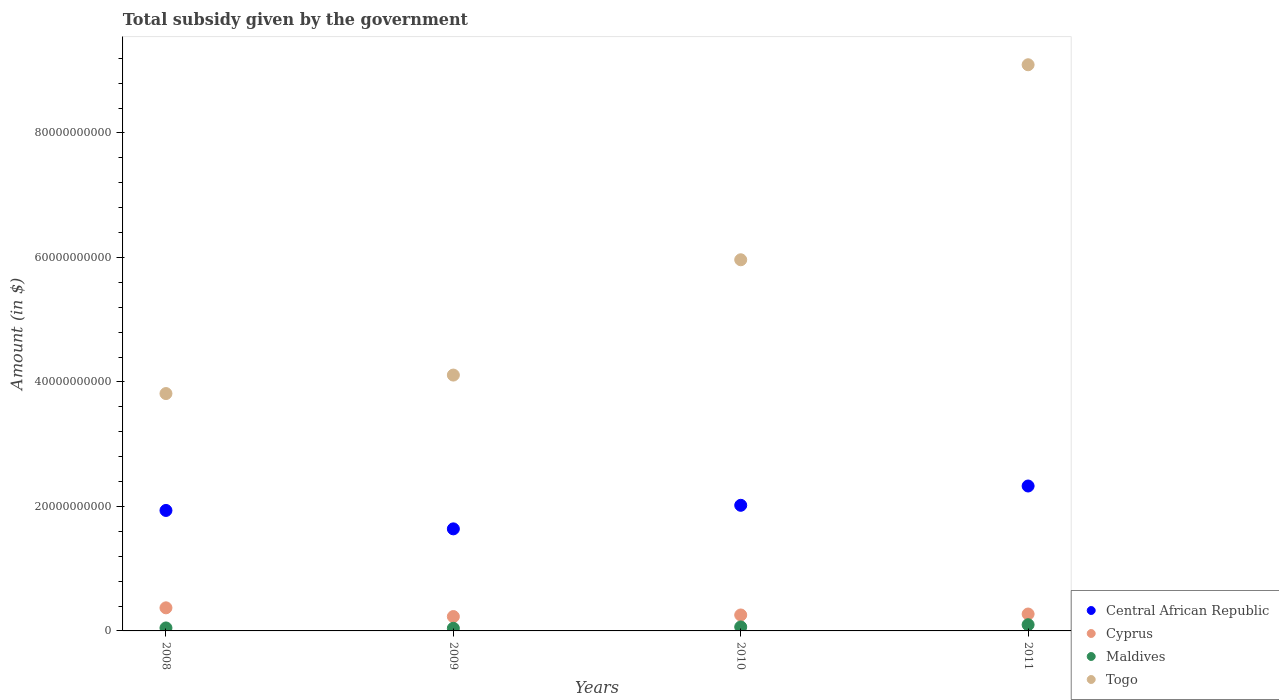What is the total revenue collected by the government in Cyprus in 2011?
Your answer should be very brief. 2.71e+09. Across all years, what is the maximum total revenue collected by the government in Maldives?
Offer a terse response. 9.97e+08. Across all years, what is the minimum total revenue collected by the government in Cyprus?
Keep it short and to the point. 2.31e+09. In which year was the total revenue collected by the government in Central African Republic maximum?
Your answer should be compact. 2011. In which year was the total revenue collected by the government in Maldives minimum?
Provide a succinct answer. 2009. What is the total total revenue collected by the government in Cyprus in the graph?
Offer a very short reply. 1.13e+1. What is the difference between the total revenue collected by the government in Maldives in 2009 and that in 2010?
Provide a succinct answer. -2.17e+08. What is the difference between the total revenue collected by the government in Central African Republic in 2011 and the total revenue collected by the government in Togo in 2010?
Keep it short and to the point. -3.63e+1. What is the average total revenue collected by the government in Togo per year?
Ensure brevity in your answer.  5.75e+1. In the year 2010, what is the difference between the total revenue collected by the government in Cyprus and total revenue collected by the government in Central African Republic?
Offer a terse response. -1.76e+1. What is the ratio of the total revenue collected by the government in Central African Republic in 2008 to that in 2009?
Your response must be concise. 1.18. Is the total revenue collected by the government in Togo in 2008 less than that in 2009?
Your response must be concise. Yes. Is the difference between the total revenue collected by the government in Cyprus in 2008 and 2011 greater than the difference between the total revenue collected by the government in Central African Republic in 2008 and 2011?
Offer a very short reply. Yes. What is the difference between the highest and the second highest total revenue collected by the government in Maldives?
Your answer should be very brief. 3.58e+08. What is the difference between the highest and the lowest total revenue collected by the government in Central African Republic?
Make the answer very short. 6.88e+09. In how many years, is the total revenue collected by the government in Togo greater than the average total revenue collected by the government in Togo taken over all years?
Offer a terse response. 2. Is the sum of the total revenue collected by the government in Cyprus in 2008 and 2010 greater than the maximum total revenue collected by the government in Maldives across all years?
Provide a succinct answer. Yes. Is it the case that in every year, the sum of the total revenue collected by the government in Togo and total revenue collected by the government in Maldives  is greater than the sum of total revenue collected by the government in Cyprus and total revenue collected by the government in Central African Republic?
Give a very brief answer. No. Is the total revenue collected by the government in Maldives strictly greater than the total revenue collected by the government in Togo over the years?
Give a very brief answer. No. Is the total revenue collected by the government in Togo strictly less than the total revenue collected by the government in Maldives over the years?
Give a very brief answer. No. Does the graph contain any zero values?
Provide a succinct answer. No. How many legend labels are there?
Make the answer very short. 4. What is the title of the graph?
Ensure brevity in your answer.  Total subsidy given by the government. Does "Japan" appear as one of the legend labels in the graph?
Give a very brief answer. No. What is the label or title of the Y-axis?
Provide a short and direct response. Amount (in $). What is the Amount (in $) of Central African Republic in 2008?
Keep it short and to the point. 1.94e+1. What is the Amount (in $) of Cyprus in 2008?
Your answer should be compact. 3.71e+09. What is the Amount (in $) of Maldives in 2008?
Ensure brevity in your answer.  4.79e+08. What is the Amount (in $) in Togo in 2008?
Offer a terse response. 3.81e+1. What is the Amount (in $) in Central African Republic in 2009?
Ensure brevity in your answer.  1.64e+1. What is the Amount (in $) of Cyprus in 2009?
Provide a succinct answer. 2.31e+09. What is the Amount (in $) in Maldives in 2009?
Offer a terse response. 4.22e+08. What is the Amount (in $) of Togo in 2009?
Provide a succinct answer. 4.11e+1. What is the Amount (in $) in Central African Republic in 2010?
Keep it short and to the point. 2.02e+1. What is the Amount (in $) in Cyprus in 2010?
Your answer should be compact. 2.56e+09. What is the Amount (in $) in Maldives in 2010?
Your response must be concise. 6.39e+08. What is the Amount (in $) in Togo in 2010?
Keep it short and to the point. 5.96e+1. What is the Amount (in $) of Central African Republic in 2011?
Give a very brief answer. 2.33e+1. What is the Amount (in $) in Cyprus in 2011?
Provide a short and direct response. 2.71e+09. What is the Amount (in $) of Maldives in 2011?
Give a very brief answer. 9.97e+08. What is the Amount (in $) of Togo in 2011?
Offer a terse response. 9.10e+1. Across all years, what is the maximum Amount (in $) of Central African Republic?
Offer a terse response. 2.33e+1. Across all years, what is the maximum Amount (in $) of Cyprus?
Your response must be concise. 3.71e+09. Across all years, what is the maximum Amount (in $) of Maldives?
Keep it short and to the point. 9.97e+08. Across all years, what is the maximum Amount (in $) in Togo?
Give a very brief answer. 9.10e+1. Across all years, what is the minimum Amount (in $) of Central African Republic?
Provide a succinct answer. 1.64e+1. Across all years, what is the minimum Amount (in $) in Cyprus?
Your response must be concise. 2.31e+09. Across all years, what is the minimum Amount (in $) in Maldives?
Provide a short and direct response. 4.22e+08. Across all years, what is the minimum Amount (in $) of Togo?
Your answer should be very brief. 3.81e+1. What is the total Amount (in $) in Central African Republic in the graph?
Offer a very short reply. 7.92e+1. What is the total Amount (in $) in Cyprus in the graph?
Your answer should be very brief. 1.13e+1. What is the total Amount (in $) in Maldives in the graph?
Offer a terse response. 2.54e+09. What is the total Amount (in $) of Togo in the graph?
Offer a very short reply. 2.30e+11. What is the difference between the Amount (in $) of Central African Republic in 2008 and that in 2009?
Your answer should be very brief. 2.96e+09. What is the difference between the Amount (in $) in Cyprus in 2008 and that in 2009?
Provide a short and direct response. 1.40e+09. What is the difference between the Amount (in $) in Maldives in 2008 and that in 2009?
Your response must be concise. 5.76e+07. What is the difference between the Amount (in $) of Togo in 2008 and that in 2009?
Your response must be concise. -2.97e+09. What is the difference between the Amount (in $) in Central African Republic in 2008 and that in 2010?
Your answer should be compact. -8.27e+08. What is the difference between the Amount (in $) in Cyprus in 2008 and that in 2010?
Your answer should be compact. 1.15e+09. What is the difference between the Amount (in $) in Maldives in 2008 and that in 2010?
Your response must be concise. -1.60e+08. What is the difference between the Amount (in $) in Togo in 2008 and that in 2010?
Keep it short and to the point. -2.15e+1. What is the difference between the Amount (in $) in Central African Republic in 2008 and that in 2011?
Keep it short and to the point. -3.93e+09. What is the difference between the Amount (in $) of Cyprus in 2008 and that in 2011?
Your answer should be compact. 9.95e+08. What is the difference between the Amount (in $) of Maldives in 2008 and that in 2011?
Offer a very short reply. -5.18e+08. What is the difference between the Amount (in $) in Togo in 2008 and that in 2011?
Ensure brevity in your answer.  -5.28e+1. What is the difference between the Amount (in $) of Central African Republic in 2009 and that in 2010?
Offer a very short reply. -3.79e+09. What is the difference between the Amount (in $) in Cyprus in 2009 and that in 2010?
Your answer should be compact. -2.53e+08. What is the difference between the Amount (in $) in Maldives in 2009 and that in 2010?
Provide a short and direct response. -2.17e+08. What is the difference between the Amount (in $) in Togo in 2009 and that in 2010?
Your answer should be compact. -1.85e+1. What is the difference between the Amount (in $) of Central African Republic in 2009 and that in 2011?
Give a very brief answer. -6.88e+09. What is the difference between the Amount (in $) in Cyprus in 2009 and that in 2011?
Keep it short and to the point. -4.07e+08. What is the difference between the Amount (in $) of Maldives in 2009 and that in 2011?
Your response must be concise. -5.75e+08. What is the difference between the Amount (in $) in Togo in 2009 and that in 2011?
Ensure brevity in your answer.  -4.99e+1. What is the difference between the Amount (in $) of Central African Republic in 2010 and that in 2011?
Give a very brief answer. -3.10e+09. What is the difference between the Amount (in $) of Cyprus in 2010 and that in 2011?
Ensure brevity in your answer.  -1.53e+08. What is the difference between the Amount (in $) in Maldives in 2010 and that in 2011?
Keep it short and to the point. -3.58e+08. What is the difference between the Amount (in $) of Togo in 2010 and that in 2011?
Offer a very short reply. -3.13e+1. What is the difference between the Amount (in $) of Central African Republic in 2008 and the Amount (in $) of Cyprus in 2009?
Provide a short and direct response. 1.70e+1. What is the difference between the Amount (in $) in Central African Republic in 2008 and the Amount (in $) in Maldives in 2009?
Keep it short and to the point. 1.89e+1. What is the difference between the Amount (in $) of Central African Republic in 2008 and the Amount (in $) of Togo in 2009?
Provide a succinct answer. -2.17e+1. What is the difference between the Amount (in $) in Cyprus in 2008 and the Amount (in $) in Maldives in 2009?
Your answer should be very brief. 3.29e+09. What is the difference between the Amount (in $) of Cyprus in 2008 and the Amount (in $) of Togo in 2009?
Give a very brief answer. -3.74e+1. What is the difference between the Amount (in $) in Maldives in 2008 and the Amount (in $) in Togo in 2009?
Your answer should be compact. -4.06e+1. What is the difference between the Amount (in $) in Central African Republic in 2008 and the Amount (in $) in Cyprus in 2010?
Provide a short and direct response. 1.68e+1. What is the difference between the Amount (in $) in Central African Republic in 2008 and the Amount (in $) in Maldives in 2010?
Offer a very short reply. 1.87e+1. What is the difference between the Amount (in $) in Central African Republic in 2008 and the Amount (in $) in Togo in 2010?
Offer a terse response. -4.03e+1. What is the difference between the Amount (in $) in Cyprus in 2008 and the Amount (in $) in Maldives in 2010?
Give a very brief answer. 3.07e+09. What is the difference between the Amount (in $) in Cyprus in 2008 and the Amount (in $) in Togo in 2010?
Your answer should be very brief. -5.59e+1. What is the difference between the Amount (in $) in Maldives in 2008 and the Amount (in $) in Togo in 2010?
Provide a short and direct response. -5.91e+1. What is the difference between the Amount (in $) of Central African Republic in 2008 and the Amount (in $) of Cyprus in 2011?
Give a very brief answer. 1.66e+1. What is the difference between the Amount (in $) in Central African Republic in 2008 and the Amount (in $) in Maldives in 2011?
Ensure brevity in your answer.  1.84e+1. What is the difference between the Amount (in $) of Central African Republic in 2008 and the Amount (in $) of Togo in 2011?
Your answer should be very brief. -7.16e+1. What is the difference between the Amount (in $) of Cyprus in 2008 and the Amount (in $) of Maldives in 2011?
Provide a short and direct response. 2.71e+09. What is the difference between the Amount (in $) in Cyprus in 2008 and the Amount (in $) in Togo in 2011?
Offer a terse response. -8.72e+1. What is the difference between the Amount (in $) of Maldives in 2008 and the Amount (in $) of Togo in 2011?
Your answer should be compact. -9.05e+1. What is the difference between the Amount (in $) in Central African Republic in 2009 and the Amount (in $) in Cyprus in 2010?
Ensure brevity in your answer.  1.38e+1. What is the difference between the Amount (in $) in Central African Republic in 2009 and the Amount (in $) in Maldives in 2010?
Your answer should be very brief. 1.58e+1. What is the difference between the Amount (in $) in Central African Republic in 2009 and the Amount (in $) in Togo in 2010?
Keep it short and to the point. -4.32e+1. What is the difference between the Amount (in $) of Cyprus in 2009 and the Amount (in $) of Maldives in 2010?
Your response must be concise. 1.67e+09. What is the difference between the Amount (in $) of Cyprus in 2009 and the Amount (in $) of Togo in 2010?
Ensure brevity in your answer.  -5.73e+1. What is the difference between the Amount (in $) of Maldives in 2009 and the Amount (in $) of Togo in 2010?
Provide a short and direct response. -5.92e+1. What is the difference between the Amount (in $) in Central African Republic in 2009 and the Amount (in $) in Cyprus in 2011?
Offer a terse response. 1.37e+1. What is the difference between the Amount (in $) in Central African Republic in 2009 and the Amount (in $) in Maldives in 2011?
Offer a very short reply. 1.54e+1. What is the difference between the Amount (in $) in Central African Republic in 2009 and the Amount (in $) in Togo in 2011?
Your answer should be compact. -7.46e+1. What is the difference between the Amount (in $) of Cyprus in 2009 and the Amount (in $) of Maldives in 2011?
Provide a succinct answer. 1.31e+09. What is the difference between the Amount (in $) in Cyprus in 2009 and the Amount (in $) in Togo in 2011?
Your answer should be compact. -8.87e+1. What is the difference between the Amount (in $) of Maldives in 2009 and the Amount (in $) of Togo in 2011?
Your response must be concise. -9.05e+1. What is the difference between the Amount (in $) of Central African Republic in 2010 and the Amount (in $) of Cyprus in 2011?
Keep it short and to the point. 1.75e+1. What is the difference between the Amount (in $) of Central African Republic in 2010 and the Amount (in $) of Maldives in 2011?
Ensure brevity in your answer.  1.92e+1. What is the difference between the Amount (in $) of Central African Republic in 2010 and the Amount (in $) of Togo in 2011?
Make the answer very short. -7.08e+1. What is the difference between the Amount (in $) in Cyprus in 2010 and the Amount (in $) in Maldives in 2011?
Keep it short and to the point. 1.56e+09. What is the difference between the Amount (in $) of Cyprus in 2010 and the Amount (in $) of Togo in 2011?
Provide a short and direct response. -8.84e+1. What is the difference between the Amount (in $) of Maldives in 2010 and the Amount (in $) of Togo in 2011?
Keep it short and to the point. -9.03e+1. What is the average Amount (in $) in Central African Republic per year?
Offer a very short reply. 1.98e+1. What is the average Amount (in $) in Cyprus per year?
Your answer should be compact. 2.82e+09. What is the average Amount (in $) of Maldives per year?
Provide a succinct answer. 6.34e+08. What is the average Amount (in $) of Togo per year?
Your answer should be very brief. 5.75e+1. In the year 2008, what is the difference between the Amount (in $) of Central African Republic and Amount (in $) of Cyprus?
Ensure brevity in your answer.  1.56e+1. In the year 2008, what is the difference between the Amount (in $) in Central African Republic and Amount (in $) in Maldives?
Your answer should be very brief. 1.89e+1. In the year 2008, what is the difference between the Amount (in $) of Central African Republic and Amount (in $) of Togo?
Offer a very short reply. -1.88e+1. In the year 2008, what is the difference between the Amount (in $) in Cyprus and Amount (in $) in Maldives?
Offer a terse response. 3.23e+09. In the year 2008, what is the difference between the Amount (in $) of Cyprus and Amount (in $) of Togo?
Give a very brief answer. -3.44e+1. In the year 2008, what is the difference between the Amount (in $) in Maldives and Amount (in $) in Togo?
Keep it short and to the point. -3.77e+1. In the year 2009, what is the difference between the Amount (in $) in Central African Republic and Amount (in $) in Cyprus?
Keep it short and to the point. 1.41e+1. In the year 2009, what is the difference between the Amount (in $) of Central African Republic and Amount (in $) of Maldives?
Ensure brevity in your answer.  1.60e+1. In the year 2009, what is the difference between the Amount (in $) in Central African Republic and Amount (in $) in Togo?
Your response must be concise. -2.47e+1. In the year 2009, what is the difference between the Amount (in $) of Cyprus and Amount (in $) of Maldives?
Your answer should be very brief. 1.89e+09. In the year 2009, what is the difference between the Amount (in $) of Cyprus and Amount (in $) of Togo?
Provide a succinct answer. -3.88e+1. In the year 2009, what is the difference between the Amount (in $) of Maldives and Amount (in $) of Togo?
Your answer should be compact. -4.07e+1. In the year 2010, what is the difference between the Amount (in $) of Central African Republic and Amount (in $) of Cyprus?
Provide a short and direct response. 1.76e+1. In the year 2010, what is the difference between the Amount (in $) of Central African Republic and Amount (in $) of Maldives?
Provide a short and direct response. 1.95e+1. In the year 2010, what is the difference between the Amount (in $) in Central African Republic and Amount (in $) in Togo?
Your answer should be very brief. -3.94e+1. In the year 2010, what is the difference between the Amount (in $) of Cyprus and Amount (in $) of Maldives?
Your answer should be very brief. 1.92e+09. In the year 2010, what is the difference between the Amount (in $) in Cyprus and Amount (in $) in Togo?
Your answer should be compact. -5.71e+1. In the year 2010, what is the difference between the Amount (in $) of Maldives and Amount (in $) of Togo?
Offer a terse response. -5.90e+1. In the year 2011, what is the difference between the Amount (in $) of Central African Republic and Amount (in $) of Cyprus?
Give a very brief answer. 2.06e+1. In the year 2011, what is the difference between the Amount (in $) in Central African Republic and Amount (in $) in Maldives?
Your response must be concise. 2.23e+1. In the year 2011, what is the difference between the Amount (in $) in Central African Republic and Amount (in $) in Togo?
Offer a very short reply. -6.77e+1. In the year 2011, what is the difference between the Amount (in $) of Cyprus and Amount (in $) of Maldives?
Your response must be concise. 1.72e+09. In the year 2011, what is the difference between the Amount (in $) in Cyprus and Amount (in $) in Togo?
Offer a very short reply. -8.82e+1. In the year 2011, what is the difference between the Amount (in $) in Maldives and Amount (in $) in Togo?
Your answer should be very brief. -9.00e+1. What is the ratio of the Amount (in $) in Central African Republic in 2008 to that in 2009?
Provide a short and direct response. 1.18. What is the ratio of the Amount (in $) in Cyprus in 2008 to that in 2009?
Keep it short and to the point. 1.61. What is the ratio of the Amount (in $) in Maldives in 2008 to that in 2009?
Provide a succinct answer. 1.14. What is the ratio of the Amount (in $) of Togo in 2008 to that in 2009?
Offer a very short reply. 0.93. What is the ratio of the Amount (in $) in Central African Republic in 2008 to that in 2010?
Offer a very short reply. 0.96. What is the ratio of the Amount (in $) of Cyprus in 2008 to that in 2010?
Keep it short and to the point. 1.45. What is the ratio of the Amount (in $) in Maldives in 2008 to that in 2010?
Your answer should be very brief. 0.75. What is the ratio of the Amount (in $) of Togo in 2008 to that in 2010?
Your answer should be compact. 0.64. What is the ratio of the Amount (in $) of Central African Republic in 2008 to that in 2011?
Give a very brief answer. 0.83. What is the ratio of the Amount (in $) of Cyprus in 2008 to that in 2011?
Your answer should be compact. 1.37. What is the ratio of the Amount (in $) of Maldives in 2008 to that in 2011?
Keep it short and to the point. 0.48. What is the ratio of the Amount (in $) of Togo in 2008 to that in 2011?
Keep it short and to the point. 0.42. What is the ratio of the Amount (in $) of Central African Republic in 2009 to that in 2010?
Your answer should be very brief. 0.81. What is the ratio of the Amount (in $) of Cyprus in 2009 to that in 2010?
Your response must be concise. 0.9. What is the ratio of the Amount (in $) of Maldives in 2009 to that in 2010?
Your answer should be very brief. 0.66. What is the ratio of the Amount (in $) in Togo in 2009 to that in 2010?
Your answer should be compact. 0.69. What is the ratio of the Amount (in $) of Central African Republic in 2009 to that in 2011?
Your answer should be compact. 0.7. What is the ratio of the Amount (in $) of Cyprus in 2009 to that in 2011?
Offer a very short reply. 0.85. What is the ratio of the Amount (in $) in Maldives in 2009 to that in 2011?
Give a very brief answer. 0.42. What is the ratio of the Amount (in $) in Togo in 2009 to that in 2011?
Offer a terse response. 0.45. What is the ratio of the Amount (in $) in Central African Republic in 2010 to that in 2011?
Keep it short and to the point. 0.87. What is the ratio of the Amount (in $) in Cyprus in 2010 to that in 2011?
Provide a short and direct response. 0.94. What is the ratio of the Amount (in $) in Maldives in 2010 to that in 2011?
Ensure brevity in your answer.  0.64. What is the ratio of the Amount (in $) of Togo in 2010 to that in 2011?
Ensure brevity in your answer.  0.66. What is the difference between the highest and the second highest Amount (in $) of Central African Republic?
Your response must be concise. 3.10e+09. What is the difference between the highest and the second highest Amount (in $) in Cyprus?
Give a very brief answer. 9.95e+08. What is the difference between the highest and the second highest Amount (in $) in Maldives?
Your answer should be very brief. 3.58e+08. What is the difference between the highest and the second highest Amount (in $) of Togo?
Provide a short and direct response. 3.13e+1. What is the difference between the highest and the lowest Amount (in $) in Central African Republic?
Your answer should be compact. 6.88e+09. What is the difference between the highest and the lowest Amount (in $) in Cyprus?
Ensure brevity in your answer.  1.40e+09. What is the difference between the highest and the lowest Amount (in $) of Maldives?
Offer a very short reply. 5.75e+08. What is the difference between the highest and the lowest Amount (in $) in Togo?
Your response must be concise. 5.28e+1. 